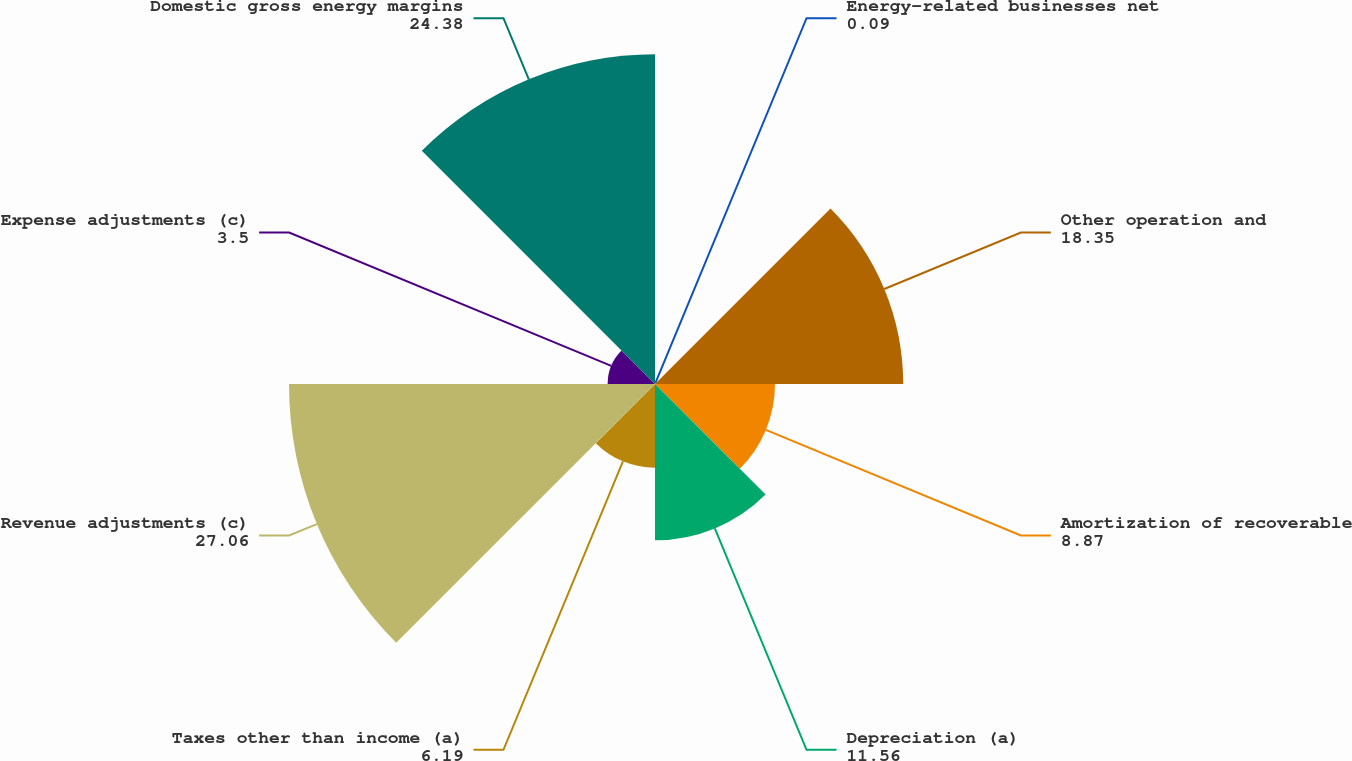Convert chart. <chart><loc_0><loc_0><loc_500><loc_500><pie_chart><fcel>Energy-related businesses net<fcel>Other operation and<fcel>Amortization of recoverable<fcel>Depreciation (a)<fcel>Taxes other than income (a)<fcel>Revenue adjustments (c)<fcel>Expense adjustments (c)<fcel>Domestic gross energy margins<nl><fcel>0.09%<fcel>18.35%<fcel>8.87%<fcel>11.56%<fcel>6.19%<fcel>27.06%<fcel>3.5%<fcel>24.38%<nl></chart> 